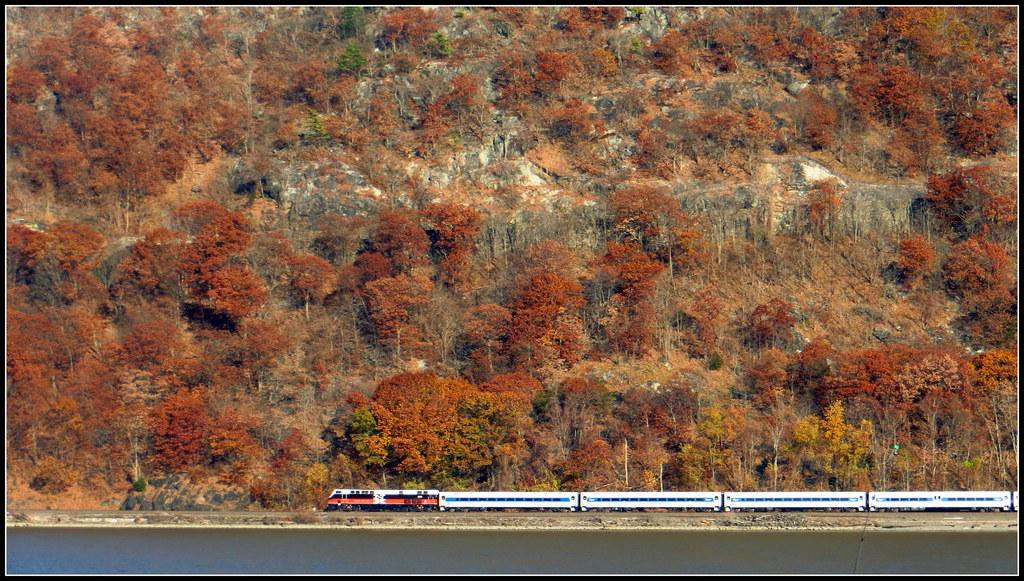What is the main subject of the image? There is a train in the image. What can be seen at the bottom of the image? There is water at the bottom side of the image. What type of vegetation is present in the image? There are trees in the image. What geographical feature is visible in the image? There are mountains in the image. What does the mom say about the letters in the image? There is no mom or letters present in the image. 